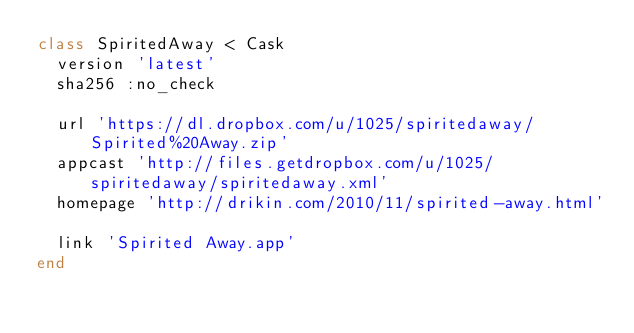<code> <loc_0><loc_0><loc_500><loc_500><_Ruby_>class SpiritedAway < Cask
  version 'latest'
  sha256 :no_check

  url 'https://dl.dropbox.com/u/1025/spiritedaway/Spirited%20Away.zip'
  appcast 'http://files.getdropbox.com/u/1025/spiritedaway/spiritedaway.xml'
  homepage 'http://drikin.com/2010/11/spirited-away.html'

  link 'Spirited Away.app'
end
</code> 